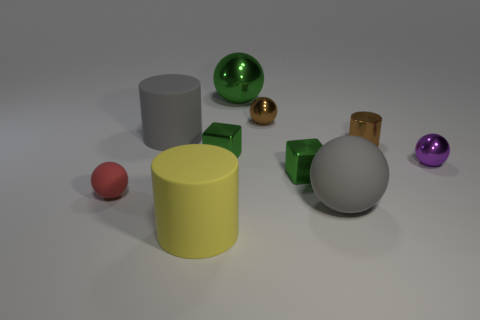How many other objects are the same material as the brown cylinder?
Ensure brevity in your answer.  5. There is a small thing that is both in front of the small metal cylinder and right of the gray rubber ball; what is it made of?
Your response must be concise. Metal. What number of small objects are either brown metal balls or green blocks?
Provide a succinct answer. 3. The yellow matte object has what size?
Your response must be concise. Large. What is the shape of the purple object?
Keep it short and to the point. Sphere. Is there anything else that is the same shape as the small red thing?
Your answer should be compact. Yes. Are there fewer yellow things behind the large yellow thing than tiny metallic cubes?
Provide a short and direct response. Yes. There is a big matte cylinder to the left of the big yellow cylinder; is its color the same as the large metal thing?
Keep it short and to the point. No. What number of metal objects are tiny purple objects or large things?
Your answer should be compact. 2. Are there any other things that have the same size as the gray matte sphere?
Your answer should be very brief. Yes. 